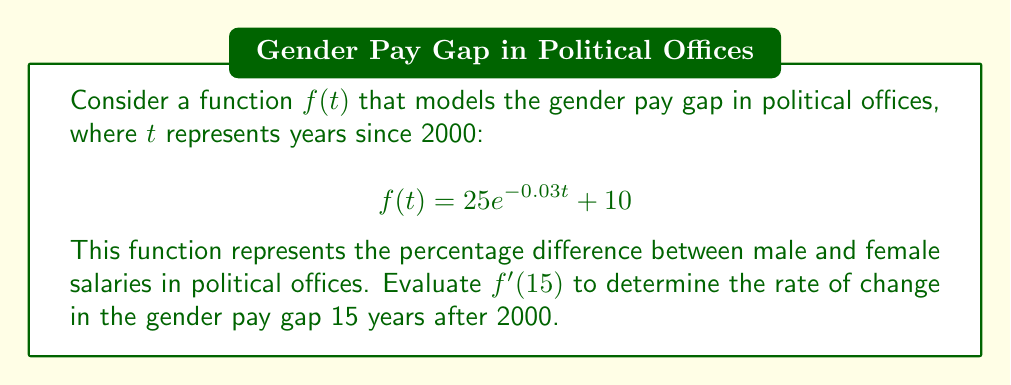Help me with this question. To find $f'(15)$, we need to follow these steps:

1) First, let's find the derivative of $f(t)$:
   $$f(t) = 25e^{-0.03t} + 10$$
   
   The derivative of $e^x$ is $e^x$, and the derivative of a constant is 0.
   Using the chain rule, we get:
   
   $$f'(t) = 25 \cdot (-0.03) \cdot e^{-0.03t} + 0$$
   $$f'(t) = -0.75e^{-0.03t}$$

2) Now that we have $f'(t)$, we can evaluate it at $t=15$:
   
   $$f'(15) = -0.75e^{-0.03(15)}$$

3) Let's calculate this:
   $$f'(15) = -0.75e^{-0.45}$$
   $$f'(15) = -0.75 \cdot 0.6376$$
   $$f'(15) = -0.4782$$

4) Interpreting the result: The rate of change of the gender pay gap 15 years after 2000 (i.e., in 2015) is approximately -0.4782% per year. The negative sign indicates that the gap is decreasing.
Answer: $-0.4782\%$ per year 